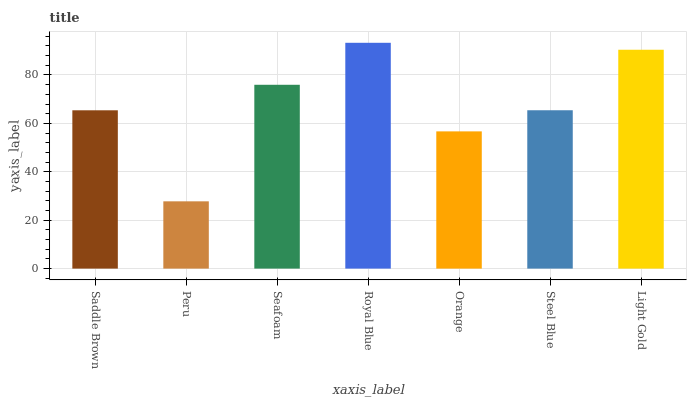Is Peru the minimum?
Answer yes or no. Yes. Is Royal Blue the maximum?
Answer yes or no. Yes. Is Seafoam the minimum?
Answer yes or no. No. Is Seafoam the maximum?
Answer yes or no. No. Is Seafoam greater than Peru?
Answer yes or no. Yes. Is Peru less than Seafoam?
Answer yes or no. Yes. Is Peru greater than Seafoam?
Answer yes or no. No. Is Seafoam less than Peru?
Answer yes or no. No. Is Steel Blue the high median?
Answer yes or no. Yes. Is Steel Blue the low median?
Answer yes or no. Yes. Is Orange the high median?
Answer yes or no. No. Is Light Gold the low median?
Answer yes or no. No. 